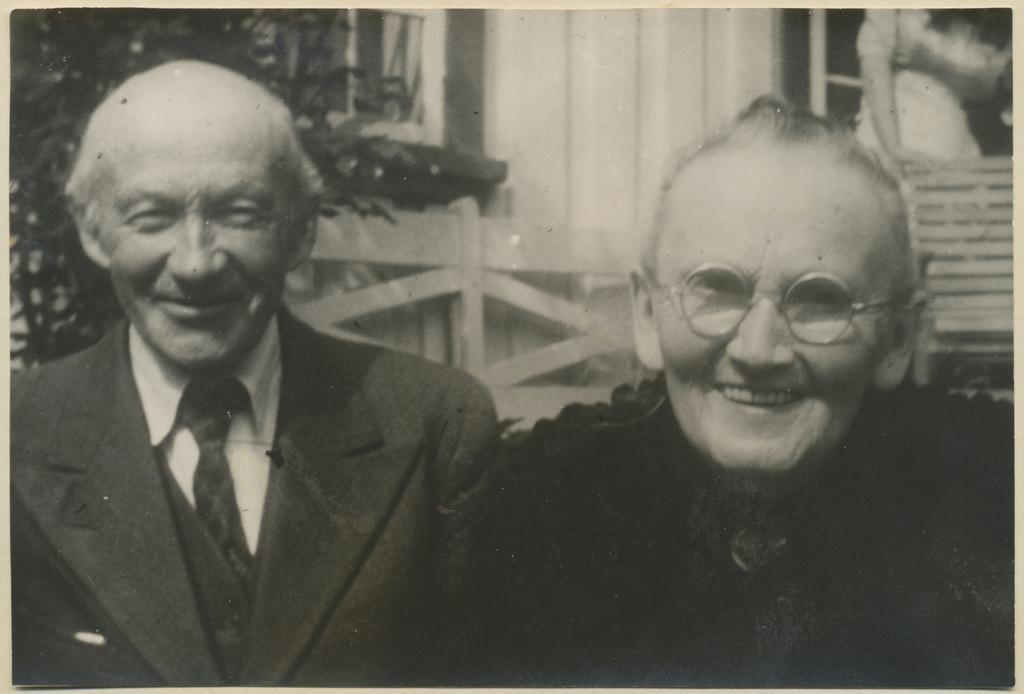Please provide a concise description of this image. It is a black and white image. In this image there are two people having a smile on their faces. Behind them there is a chair. There is a person standing. On the left side of the image there is a tree. There is a wooden railing. In the background of the image there are glass windows and a wall. 